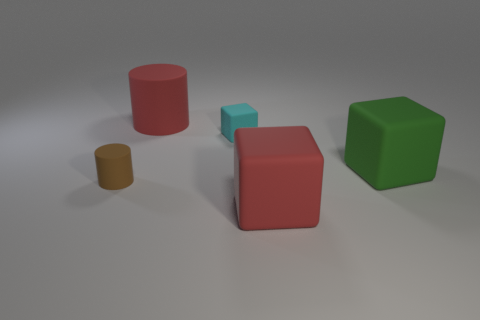Are there any patterns or similarities among the objects in the image? Yes, the objects in the image share geometric characteristics, such as defined edges and flat surfaces indicative of solid geometric shapes. The large red cylinder and red cube also share the same color, indicating a possible categorical relationship based on their hue. What can you infer about the setting of these objects based on their shadows? The shadows of the objects are visible and extend to the right, indicating the light source is to the left of the scene. The soft edges of the shadows suggest a diffuse light source, possibly indicative of an indoor setting with artificial lighting. 